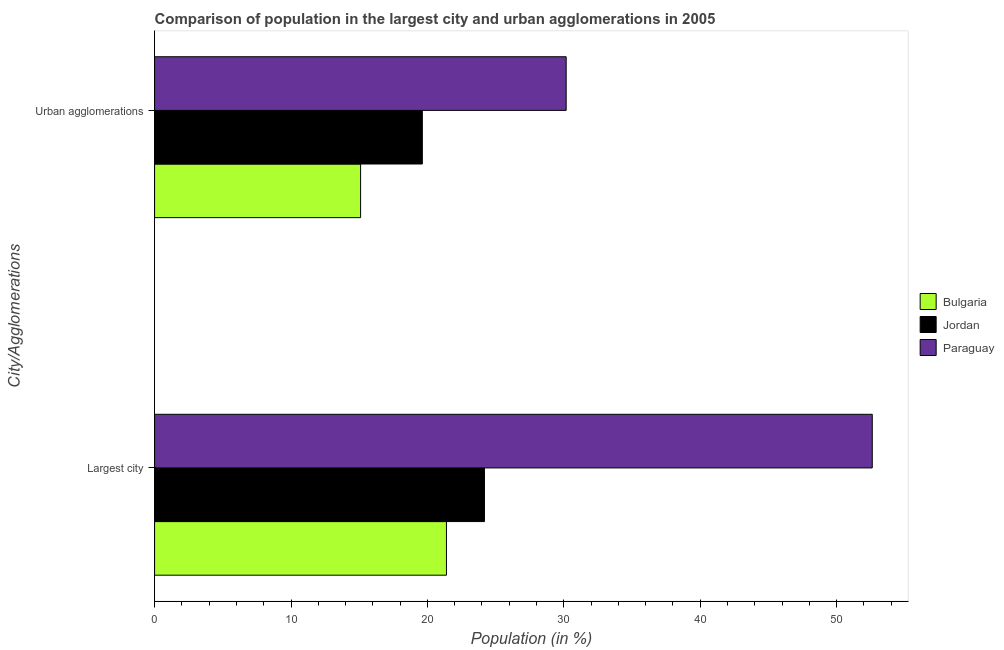How many different coloured bars are there?
Offer a terse response. 3. How many bars are there on the 1st tick from the top?
Offer a very short reply. 3. How many bars are there on the 1st tick from the bottom?
Keep it short and to the point. 3. What is the label of the 2nd group of bars from the top?
Give a very brief answer. Largest city. What is the population in urban agglomerations in Jordan?
Ensure brevity in your answer.  19.63. Across all countries, what is the maximum population in urban agglomerations?
Ensure brevity in your answer.  30.17. Across all countries, what is the minimum population in the largest city?
Offer a terse response. 21.4. In which country was the population in urban agglomerations maximum?
Your response must be concise. Paraguay. What is the total population in the largest city in the graph?
Keep it short and to the point. 98.18. What is the difference between the population in urban agglomerations in Bulgaria and that in Paraguay?
Ensure brevity in your answer.  -15.07. What is the difference between the population in urban agglomerations in Jordan and the population in the largest city in Bulgaria?
Keep it short and to the point. -1.77. What is the average population in the largest city per country?
Your answer should be compact. 32.73. What is the difference between the population in urban agglomerations and population in the largest city in Paraguay?
Your response must be concise. -22.44. In how many countries, is the population in urban agglomerations greater than 44 %?
Ensure brevity in your answer.  0. What is the ratio of the population in the largest city in Paraguay to that in Bulgaria?
Make the answer very short. 2.46. Is the population in the largest city in Jordan less than that in Paraguay?
Keep it short and to the point. Yes. What does the 3rd bar from the top in Urban agglomerations represents?
Ensure brevity in your answer.  Bulgaria. What does the 3rd bar from the bottom in Urban agglomerations represents?
Provide a succinct answer. Paraguay. How many bars are there?
Offer a very short reply. 6. How many countries are there in the graph?
Offer a very short reply. 3. What is the difference between two consecutive major ticks on the X-axis?
Offer a very short reply. 10. Does the graph contain grids?
Your answer should be compact. No. How are the legend labels stacked?
Your answer should be compact. Vertical. What is the title of the graph?
Keep it short and to the point. Comparison of population in the largest city and urban agglomerations in 2005. What is the label or title of the X-axis?
Your response must be concise. Population (in %). What is the label or title of the Y-axis?
Your answer should be very brief. City/Agglomerations. What is the Population (in %) of Bulgaria in Largest city?
Make the answer very short. 21.4. What is the Population (in %) of Jordan in Largest city?
Make the answer very short. 24.18. What is the Population (in %) in Paraguay in Largest city?
Give a very brief answer. 52.61. What is the Population (in %) of Bulgaria in Urban agglomerations?
Offer a very short reply. 15.1. What is the Population (in %) in Jordan in Urban agglomerations?
Your answer should be compact. 19.63. What is the Population (in %) in Paraguay in Urban agglomerations?
Offer a terse response. 30.17. Across all City/Agglomerations, what is the maximum Population (in %) of Bulgaria?
Provide a short and direct response. 21.4. Across all City/Agglomerations, what is the maximum Population (in %) of Jordan?
Give a very brief answer. 24.18. Across all City/Agglomerations, what is the maximum Population (in %) of Paraguay?
Your response must be concise. 52.61. Across all City/Agglomerations, what is the minimum Population (in %) in Bulgaria?
Make the answer very short. 15.1. Across all City/Agglomerations, what is the minimum Population (in %) in Jordan?
Ensure brevity in your answer.  19.63. Across all City/Agglomerations, what is the minimum Population (in %) of Paraguay?
Offer a terse response. 30.17. What is the total Population (in %) of Bulgaria in the graph?
Provide a short and direct response. 36.5. What is the total Population (in %) in Jordan in the graph?
Provide a short and direct response. 43.81. What is the total Population (in %) in Paraguay in the graph?
Offer a terse response. 82.78. What is the difference between the Population (in %) in Bulgaria in Largest city and that in Urban agglomerations?
Provide a short and direct response. 6.29. What is the difference between the Population (in %) of Jordan in Largest city and that in Urban agglomerations?
Keep it short and to the point. 4.55. What is the difference between the Population (in %) of Paraguay in Largest city and that in Urban agglomerations?
Provide a short and direct response. 22.44. What is the difference between the Population (in %) of Bulgaria in Largest city and the Population (in %) of Jordan in Urban agglomerations?
Give a very brief answer. 1.77. What is the difference between the Population (in %) in Bulgaria in Largest city and the Population (in %) in Paraguay in Urban agglomerations?
Provide a short and direct response. -8.78. What is the difference between the Population (in %) in Jordan in Largest city and the Population (in %) in Paraguay in Urban agglomerations?
Give a very brief answer. -5.99. What is the average Population (in %) of Bulgaria per City/Agglomerations?
Offer a terse response. 18.25. What is the average Population (in %) in Jordan per City/Agglomerations?
Make the answer very short. 21.9. What is the average Population (in %) in Paraguay per City/Agglomerations?
Your response must be concise. 41.39. What is the difference between the Population (in %) in Bulgaria and Population (in %) in Jordan in Largest city?
Make the answer very short. -2.78. What is the difference between the Population (in %) of Bulgaria and Population (in %) of Paraguay in Largest city?
Your response must be concise. -31.21. What is the difference between the Population (in %) in Jordan and Population (in %) in Paraguay in Largest city?
Your response must be concise. -28.43. What is the difference between the Population (in %) of Bulgaria and Population (in %) of Jordan in Urban agglomerations?
Give a very brief answer. -4.53. What is the difference between the Population (in %) of Bulgaria and Population (in %) of Paraguay in Urban agglomerations?
Offer a terse response. -15.07. What is the difference between the Population (in %) in Jordan and Population (in %) in Paraguay in Urban agglomerations?
Provide a short and direct response. -10.54. What is the ratio of the Population (in %) in Bulgaria in Largest city to that in Urban agglomerations?
Provide a short and direct response. 1.42. What is the ratio of the Population (in %) in Jordan in Largest city to that in Urban agglomerations?
Give a very brief answer. 1.23. What is the ratio of the Population (in %) in Paraguay in Largest city to that in Urban agglomerations?
Keep it short and to the point. 1.74. What is the difference between the highest and the second highest Population (in %) in Bulgaria?
Your answer should be compact. 6.29. What is the difference between the highest and the second highest Population (in %) in Jordan?
Your answer should be compact. 4.55. What is the difference between the highest and the second highest Population (in %) in Paraguay?
Your response must be concise. 22.44. What is the difference between the highest and the lowest Population (in %) of Bulgaria?
Provide a short and direct response. 6.29. What is the difference between the highest and the lowest Population (in %) of Jordan?
Give a very brief answer. 4.55. What is the difference between the highest and the lowest Population (in %) in Paraguay?
Make the answer very short. 22.44. 